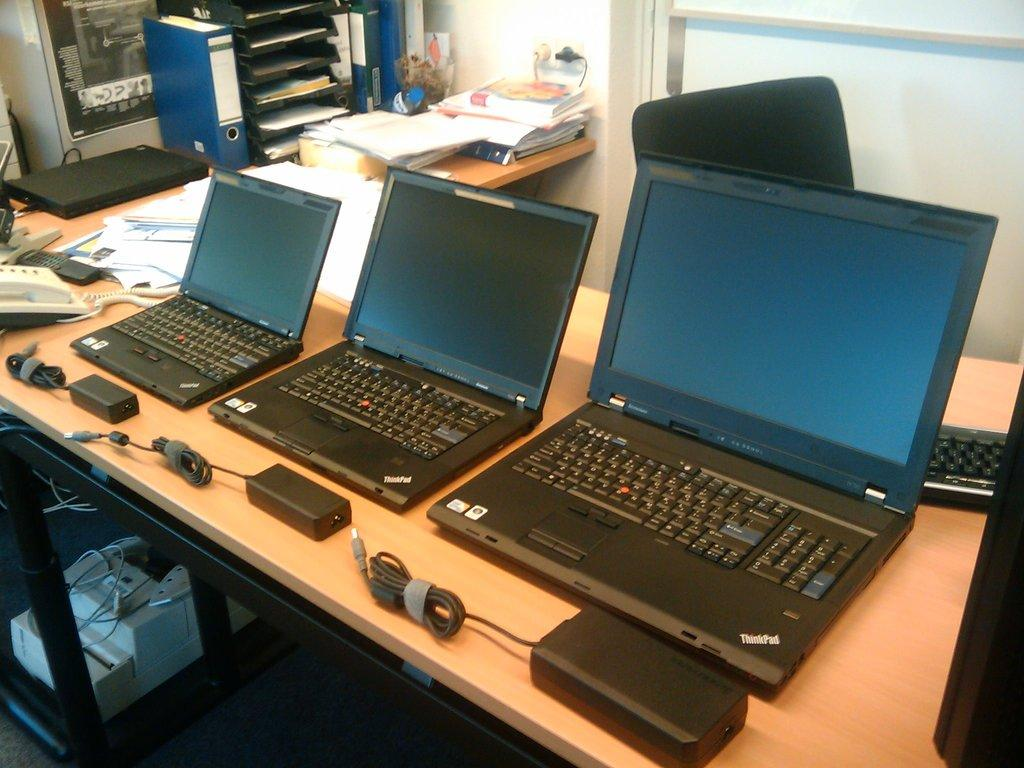<image>
Summarize the visual content of the image. Three laptops of differing sizes all have ThinkPad displayed in the corner. 